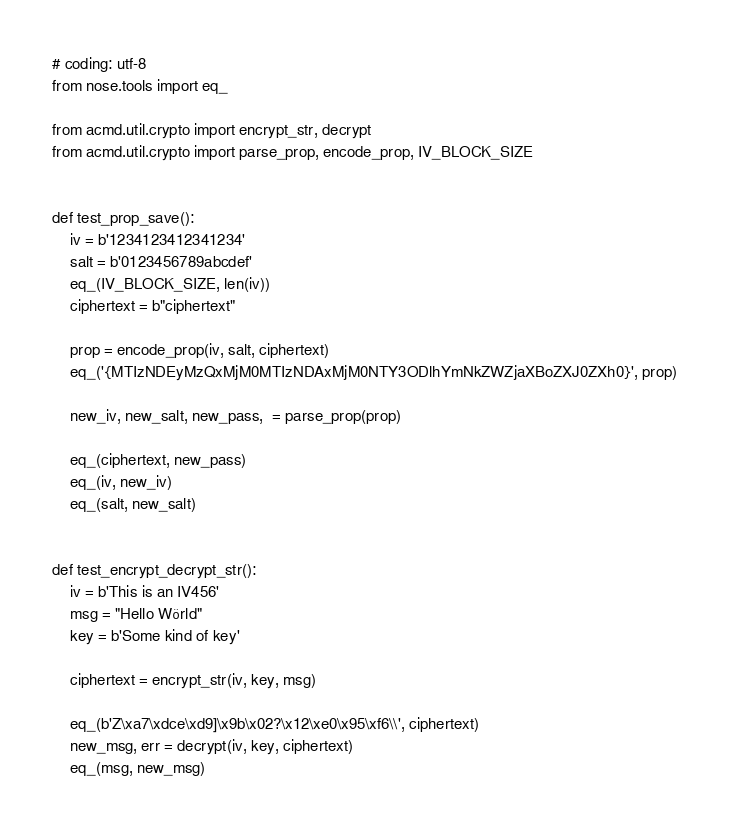<code> <loc_0><loc_0><loc_500><loc_500><_Python_># coding: utf-8
from nose.tools import eq_

from acmd.util.crypto import encrypt_str, decrypt
from acmd.util.crypto import parse_prop, encode_prop, IV_BLOCK_SIZE


def test_prop_save():
    iv = b'1234123412341234'
    salt = b'0123456789abcdef'
    eq_(IV_BLOCK_SIZE, len(iv))
    ciphertext = b"ciphertext"

    prop = encode_prop(iv, salt, ciphertext)
    eq_('{MTIzNDEyMzQxMjM0MTIzNDAxMjM0NTY3ODlhYmNkZWZjaXBoZXJ0ZXh0}', prop)

    new_iv, new_salt, new_pass,  = parse_prop(prop)

    eq_(ciphertext, new_pass)
    eq_(iv, new_iv)
    eq_(salt, new_salt)


def test_encrypt_decrypt_str():
    iv = b'This is an IV456'
    msg = "Hello Wörld"
    key = b'Some kind of key'

    ciphertext = encrypt_str(iv, key, msg)

    eq_(b'Z\xa7\xdce\xd9]\x9b\x02?\x12\xe0\x95\xf6\\', ciphertext)
    new_msg, err = decrypt(iv, key, ciphertext)
    eq_(msg, new_msg)
</code> 